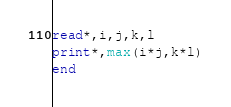<code> <loc_0><loc_0><loc_500><loc_500><_FORTRAN_>read*,i,j,k,l
print*,max(i*j,k*l)
end</code> 